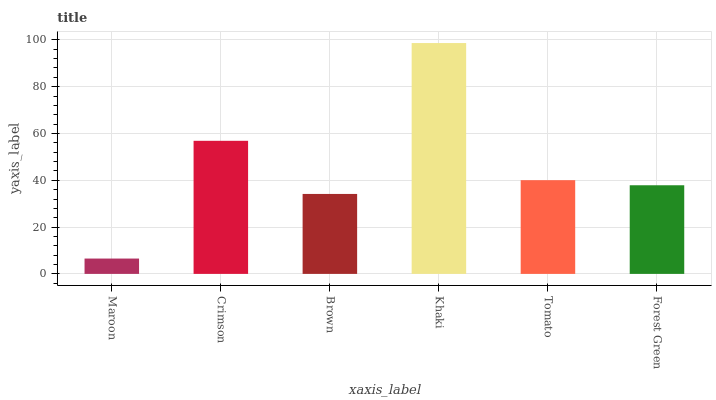Is Maroon the minimum?
Answer yes or no. Yes. Is Khaki the maximum?
Answer yes or no. Yes. Is Crimson the minimum?
Answer yes or no. No. Is Crimson the maximum?
Answer yes or no. No. Is Crimson greater than Maroon?
Answer yes or no. Yes. Is Maroon less than Crimson?
Answer yes or no. Yes. Is Maroon greater than Crimson?
Answer yes or no. No. Is Crimson less than Maroon?
Answer yes or no. No. Is Tomato the high median?
Answer yes or no. Yes. Is Forest Green the low median?
Answer yes or no. Yes. Is Maroon the high median?
Answer yes or no. No. Is Brown the low median?
Answer yes or no. No. 